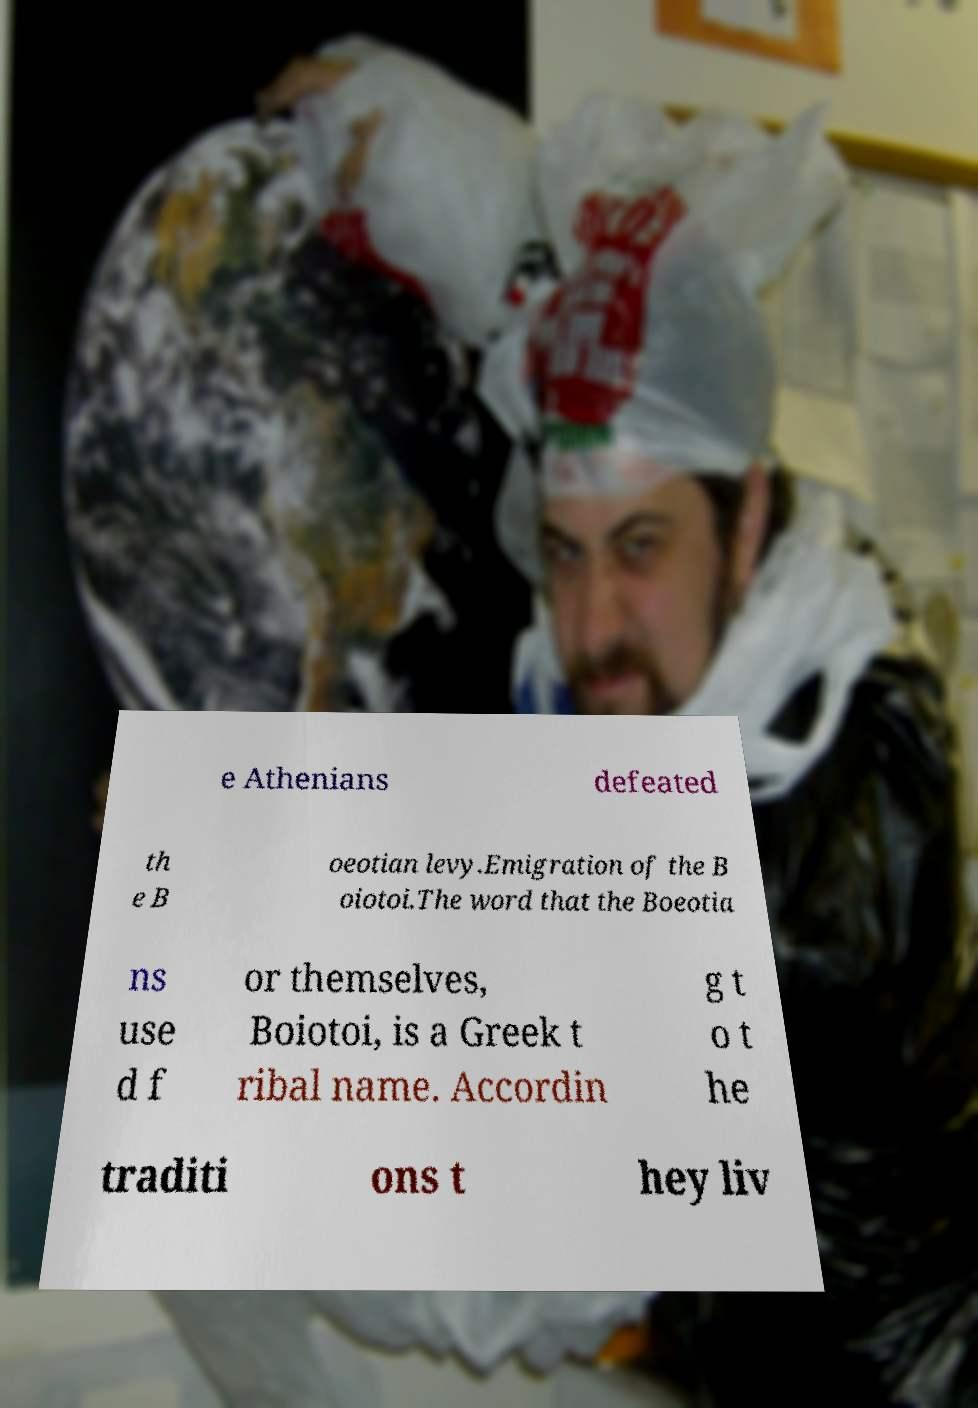Could you assist in decoding the text presented in this image and type it out clearly? e Athenians defeated th e B oeotian levy.Emigration of the B oiotoi.The word that the Boeotia ns use d f or themselves, Boiotoi, is a Greek t ribal name. Accordin g t o t he traditi ons t hey liv 